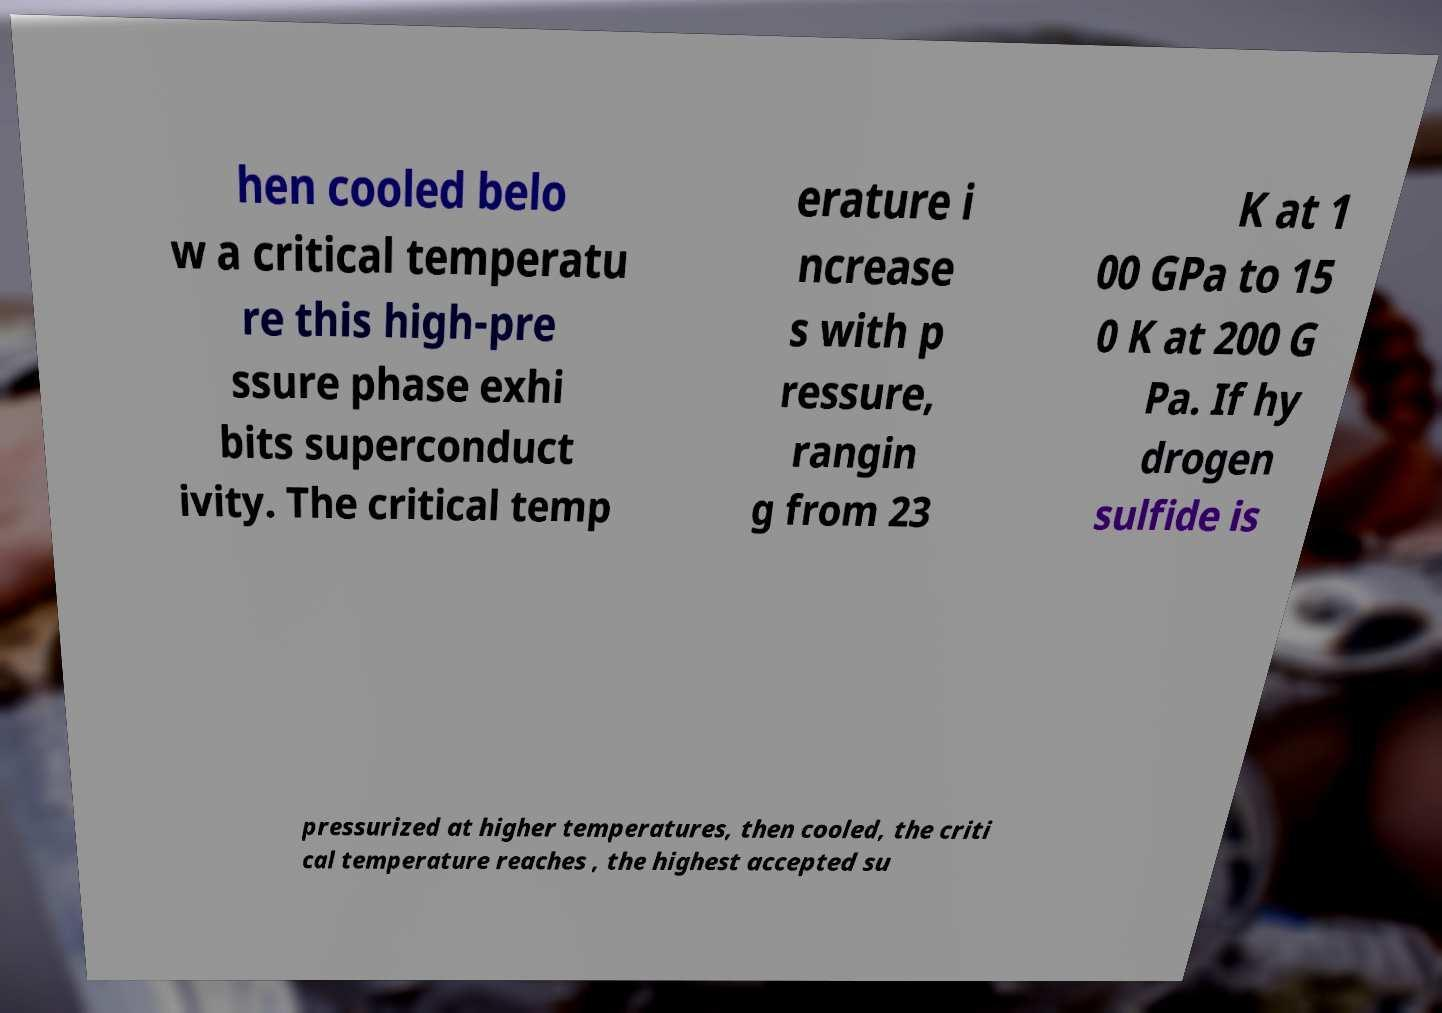Could you extract and type out the text from this image? hen cooled belo w a critical temperatu re this high-pre ssure phase exhi bits superconduct ivity. The critical temp erature i ncrease s with p ressure, rangin g from 23 K at 1 00 GPa to 15 0 K at 200 G Pa. If hy drogen sulfide is pressurized at higher temperatures, then cooled, the criti cal temperature reaches , the highest accepted su 